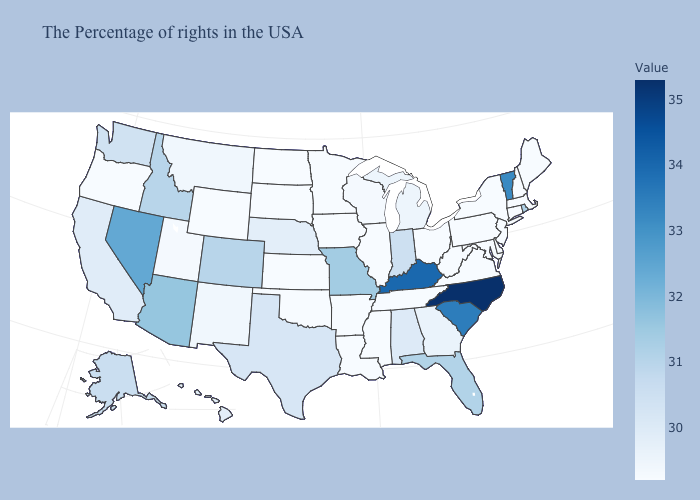Which states hav the highest value in the West?
Quick response, please. Nevada. Does the map have missing data?
Concise answer only. No. Among the states that border Nebraska , which have the highest value?
Quick response, please. Missouri. Does Missouri have the highest value in the MidWest?
Short answer required. Yes. Does the map have missing data?
Give a very brief answer. No. Among the states that border Iowa , which have the highest value?
Short answer required. Missouri. Among the states that border Texas , which have the lowest value?
Be succinct. Louisiana, Arkansas, Oklahoma. 